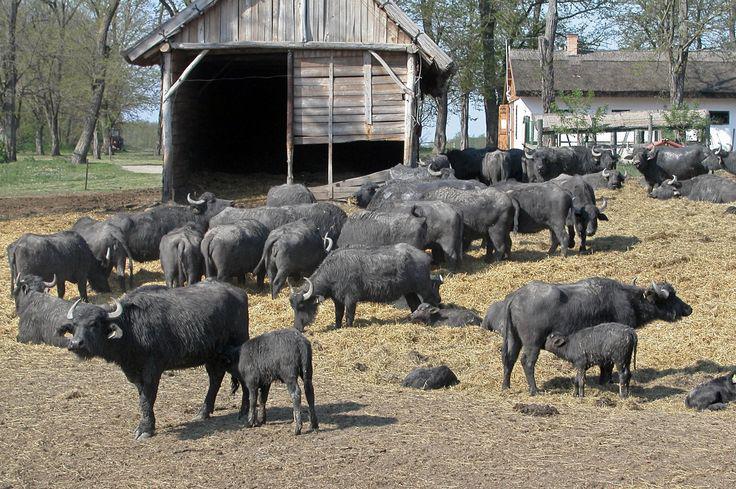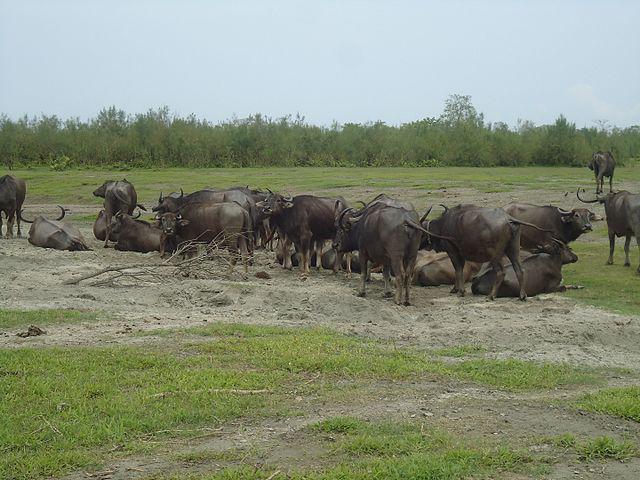The first image is the image on the left, the second image is the image on the right. Considering the images on both sides, is "There is an area of water seen behind some of the animals in the image on the left." valid? Answer yes or no. No. The first image is the image on the left, the second image is the image on the right. Examine the images to the left and right. Is the description "An image shows water buffalo standing with a pool of water behind them, but not in front of them." accurate? Answer yes or no. No. 